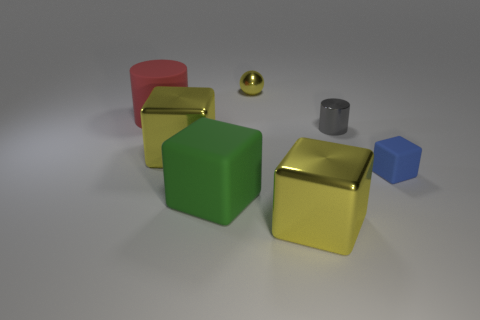How many shiny blocks have the same color as the tiny ball? There are two shiny blocks that share the same color as the tiny golden ball. These are the shiny gold-colored blocks situated near the center and the left side of the image. 